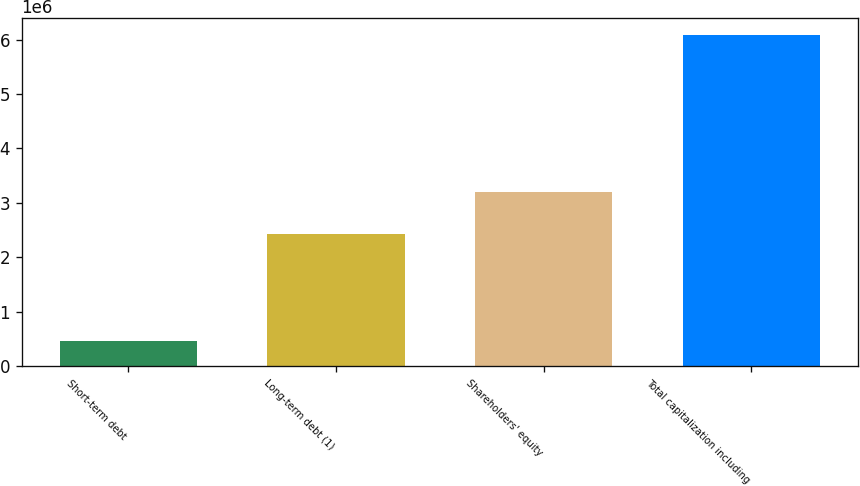<chart> <loc_0><loc_0><loc_500><loc_500><bar_chart><fcel>Short-term debt<fcel>Long-term debt (1)<fcel>Shareholders' equity<fcel>Total capitalization including<nl><fcel>457927<fcel>2.43752e+06<fcel>3.1948e+06<fcel>6.09024e+06<nl></chart> 